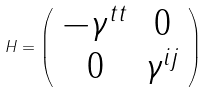Convert formula to latex. <formula><loc_0><loc_0><loc_500><loc_500>H = \left ( \begin{array} { c c } - \gamma ^ { t t } & 0 \\ 0 & \gamma ^ { i j } \end{array} \right )</formula> 